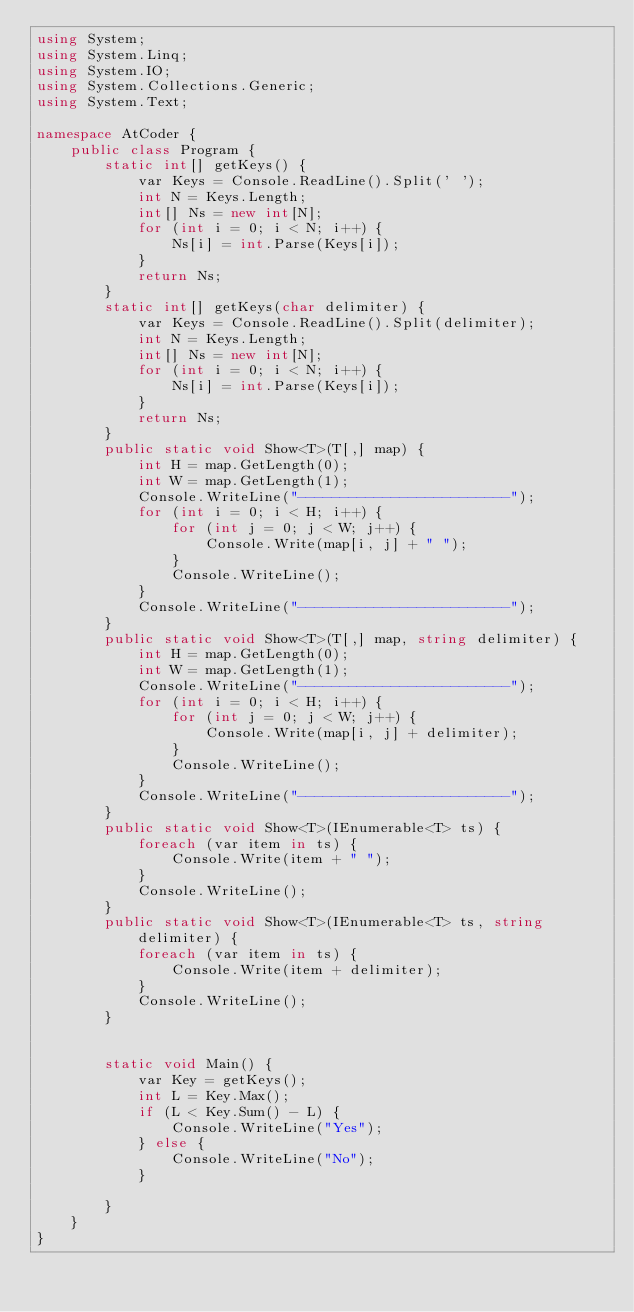Convert code to text. <code><loc_0><loc_0><loc_500><loc_500><_C#_>using System;
using System.Linq;
using System.IO;
using System.Collections.Generic;
using System.Text;

namespace AtCoder {
    public class Program {
        static int[] getKeys() {
            var Keys = Console.ReadLine().Split(' ');
            int N = Keys.Length;
            int[] Ns = new int[N];
            for (int i = 0; i < N; i++) {
                Ns[i] = int.Parse(Keys[i]);
            }
            return Ns;
        }
        static int[] getKeys(char delimiter) {
            var Keys = Console.ReadLine().Split(delimiter);
            int N = Keys.Length;
            int[] Ns = new int[N];
            for (int i = 0; i < N; i++) {
                Ns[i] = int.Parse(Keys[i]);
            }
            return Ns;
        }
        public static void Show<T>(T[,] map) {
            int H = map.GetLength(0);
            int W = map.GetLength(1);
            Console.WriteLine("-------------------------");
            for (int i = 0; i < H; i++) {
                for (int j = 0; j < W; j++) {
                    Console.Write(map[i, j] + " ");
                }
                Console.WriteLine();
            }
            Console.WriteLine("-------------------------");
        }
        public static void Show<T>(T[,] map, string delimiter) {
            int H = map.GetLength(0);
            int W = map.GetLength(1);
            Console.WriteLine("-------------------------");
            for (int i = 0; i < H; i++) {
                for (int j = 0; j < W; j++) {
                    Console.Write(map[i, j] + delimiter);
                }
                Console.WriteLine();
            }
            Console.WriteLine("-------------------------");
        }
        public static void Show<T>(IEnumerable<T> ts) {
            foreach (var item in ts) {
                Console.Write(item + " ");
            }
            Console.WriteLine();
        }
        public static void Show<T>(IEnumerable<T> ts, string delimiter) {
            foreach (var item in ts) {
                Console.Write(item + delimiter);
            }
            Console.WriteLine();
        }


        static void Main() {
            var Key = getKeys();
            int L = Key.Max();
            if (L < Key.Sum() - L) {
                Console.WriteLine("Yes");
            } else {
                Console.WriteLine("No");
            }

        }
    }
}
</code> 